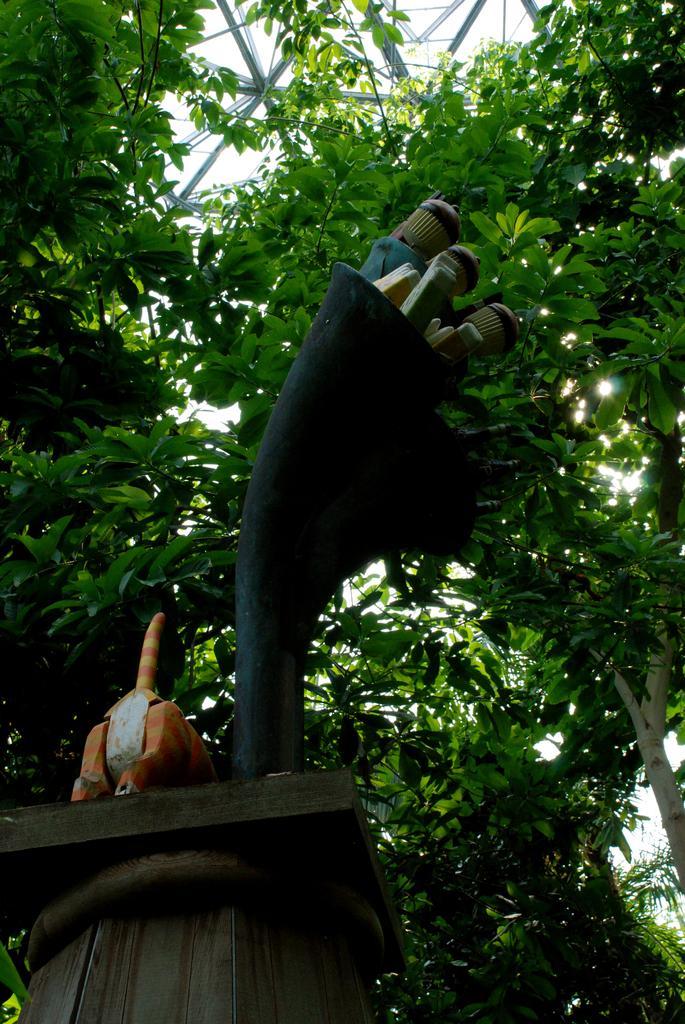Can you describe this image briefly? In this image there is a structure on the wooden stand and there is an object on the stand. In the background of the image there are trees and metal rods. 